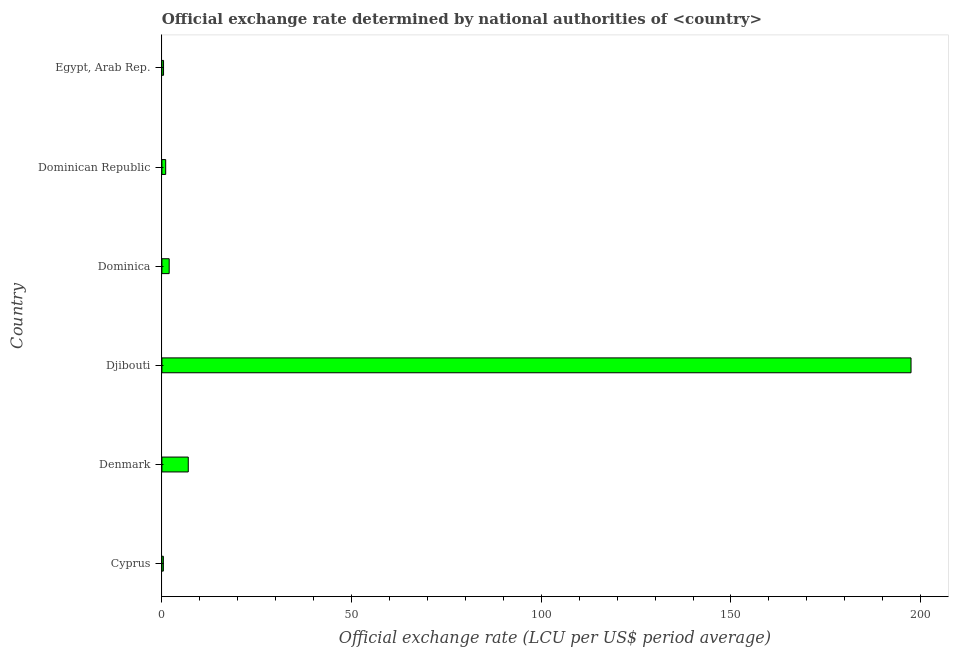Does the graph contain grids?
Offer a very short reply. No. What is the title of the graph?
Offer a terse response. Official exchange rate determined by national authorities of <country>. What is the label or title of the X-axis?
Your answer should be compact. Official exchange rate (LCU per US$ period average). What is the official exchange rate in Dominican Republic?
Keep it short and to the point. 1. Across all countries, what is the maximum official exchange rate?
Your response must be concise. 197.47. Across all countries, what is the minimum official exchange rate?
Offer a very short reply. 0.38. In which country was the official exchange rate maximum?
Offer a terse response. Djibouti. In which country was the official exchange rate minimum?
Provide a succinct answer. Cyprus. What is the sum of the official exchange rate?
Provide a short and direct response. 208.15. What is the difference between the official exchange rate in Dominican Republic and Egypt, Arab Rep.?
Offer a very short reply. 0.56. What is the average official exchange rate per country?
Offer a terse response. 34.69. What is the median official exchange rate?
Ensure brevity in your answer.  1.46. In how many countries, is the official exchange rate greater than 30 ?
Your response must be concise. 1. What is the ratio of the official exchange rate in Djibouti to that in Dominican Republic?
Offer a terse response. 197.47. Is the official exchange rate in Denmark less than that in Djibouti?
Your answer should be very brief. Yes. Is the difference between the official exchange rate in Dominican Republic and Egypt, Arab Rep. greater than the difference between any two countries?
Make the answer very short. No. What is the difference between the highest and the second highest official exchange rate?
Your answer should be compact. 190.52. What is the difference between the highest and the lowest official exchange rate?
Your answer should be compact. 197.08. Are all the bars in the graph horizontal?
Offer a terse response. Yes. What is the difference between two consecutive major ticks on the X-axis?
Offer a terse response. 50. What is the Official exchange rate (LCU per US$ period average) of Cyprus?
Ensure brevity in your answer.  0.38. What is the Official exchange rate (LCU per US$ period average) of Denmark?
Your answer should be very brief. 6.95. What is the Official exchange rate (LCU per US$ period average) in Djibouti?
Make the answer very short. 197.47. What is the Official exchange rate (LCU per US$ period average) of Dominica?
Provide a short and direct response. 1.92. What is the Official exchange rate (LCU per US$ period average) in Dominican Republic?
Ensure brevity in your answer.  1. What is the Official exchange rate (LCU per US$ period average) of Egypt, Arab Rep.?
Offer a very short reply. 0.43. What is the difference between the Official exchange rate (LCU per US$ period average) in Cyprus and Denmark?
Offer a terse response. -6.57. What is the difference between the Official exchange rate (LCU per US$ period average) in Cyprus and Djibouti?
Offer a very short reply. -197.08. What is the difference between the Official exchange rate (LCU per US$ period average) in Cyprus and Dominica?
Your response must be concise. -1.54. What is the difference between the Official exchange rate (LCU per US$ period average) in Cyprus and Dominican Republic?
Provide a succinct answer. -0.62. What is the difference between the Official exchange rate (LCU per US$ period average) in Cyprus and Egypt, Arab Rep.?
Keep it short and to the point. -0.05. What is the difference between the Official exchange rate (LCU per US$ period average) in Denmark and Djibouti?
Offer a very short reply. -190.52. What is the difference between the Official exchange rate (LCU per US$ period average) in Denmark and Dominica?
Offer a terse response. 5.03. What is the difference between the Official exchange rate (LCU per US$ period average) in Denmark and Dominican Republic?
Ensure brevity in your answer.  5.95. What is the difference between the Official exchange rate (LCU per US$ period average) in Denmark and Egypt, Arab Rep.?
Offer a terse response. 6.51. What is the difference between the Official exchange rate (LCU per US$ period average) in Djibouti and Dominica?
Your response must be concise. 195.54. What is the difference between the Official exchange rate (LCU per US$ period average) in Djibouti and Dominican Republic?
Make the answer very short. 196.47. What is the difference between the Official exchange rate (LCU per US$ period average) in Djibouti and Egypt, Arab Rep.?
Give a very brief answer. 197.03. What is the difference between the Official exchange rate (LCU per US$ period average) in Dominica and Dominican Republic?
Give a very brief answer. 0.92. What is the difference between the Official exchange rate (LCU per US$ period average) in Dominica and Egypt, Arab Rep.?
Offer a very short reply. 1.49. What is the difference between the Official exchange rate (LCU per US$ period average) in Dominican Republic and Egypt, Arab Rep.?
Your answer should be very brief. 0.57. What is the ratio of the Official exchange rate (LCU per US$ period average) in Cyprus to that in Denmark?
Offer a very short reply. 0.06. What is the ratio of the Official exchange rate (LCU per US$ period average) in Cyprus to that in Djibouti?
Provide a short and direct response. 0. What is the ratio of the Official exchange rate (LCU per US$ period average) in Cyprus to that in Dominican Republic?
Offer a terse response. 0.38. What is the ratio of the Official exchange rate (LCU per US$ period average) in Cyprus to that in Egypt, Arab Rep.?
Keep it short and to the point. 0.88. What is the ratio of the Official exchange rate (LCU per US$ period average) in Denmark to that in Djibouti?
Give a very brief answer. 0.04. What is the ratio of the Official exchange rate (LCU per US$ period average) in Denmark to that in Dominica?
Ensure brevity in your answer.  3.62. What is the ratio of the Official exchange rate (LCU per US$ period average) in Denmark to that in Dominican Republic?
Keep it short and to the point. 6.95. What is the ratio of the Official exchange rate (LCU per US$ period average) in Denmark to that in Egypt, Arab Rep.?
Provide a succinct answer. 15.98. What is the ratio of the Official exchange rate (LCU per US$ period average) in Djibouti to that in Dominica?
Provide a succinct answer. 102.78. What is the ratio of the Official exchange rate (LCU per US$ period average) in Djibouti to that in Dominican Republic?
Provide a short and direct response. 197.47. What is the ratio of the Official exchange rate (LCU per US$ period average) in Djibouti to that in Egypt, Arab Rep.?
Make the answer very short. 454.17. What is the ratio of the Official exchange rate (LCU per US$ period average) in Dominica to that in Dominican Republic?
Offer a terse response. 1.92. What is the ratio of the Official exchange rate (LCU per US$ period average) in Dominica to that in Egypt, Arab Rep.?
Your answer should be very brief. 4.42. What is the ratio of the Official exchange rate (LCU per US$ period average) in Dominican Republic to that in Egypt, Arab Rep.?
Your answer should be compact. 2.3. 